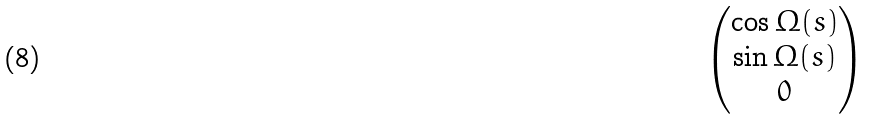<formula> <loc_0><loc_0><loc_500><loc_500>\begin{pmatrix} \cos { \mathit \Omega ( s ) } \\ \sin { \mathit \Omega ( s ) } \\ 0 \end{pmatrix}</formula> 